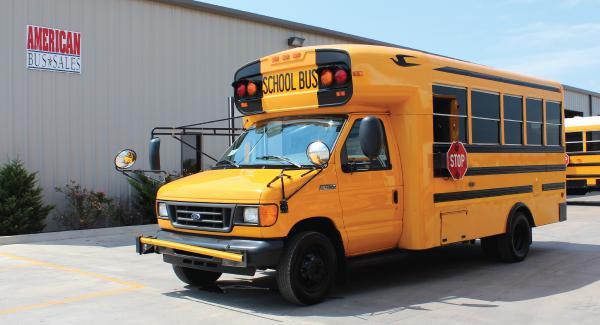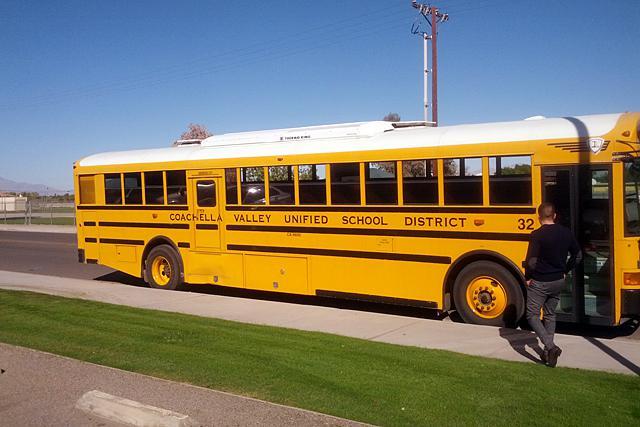The first image is the image on the left, the second image is the image on the right. Given the left and right images, does the statement "Every school bus is pointing to the left." hold true? Answer yes or no. No. The first image is the image on the left, the second image is the image on the right. Given the left and right images, does the statement "Each image contains one bus that has a non-flat front and is parked at a leftward angle, with the red sign on its side facing the camera." hold true? Answer yes or no. No. 